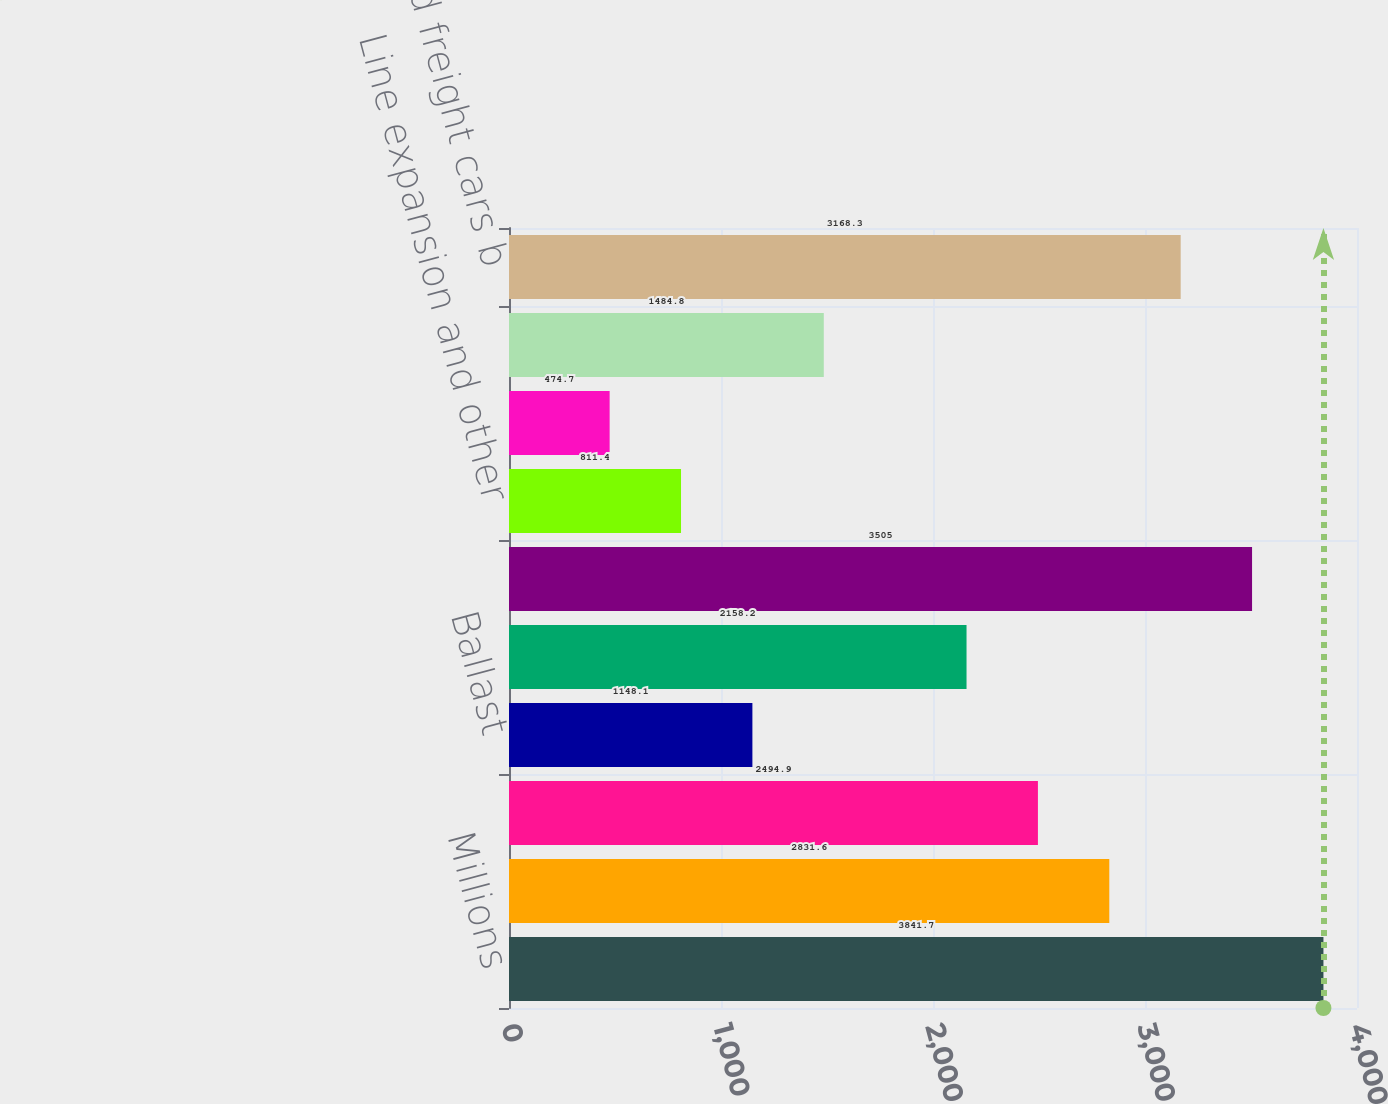Convert chart. <chart><loc_0><loc_0><loc_500><loc_500><bar_chart><fcel>Millions<fcel>Rail and other track material<fcel>Ties<fcel>Ballast<fcel>Other a<fcel>Total road infrastructure<fcel>Line expansion and other<fcel>Commercial facilities<fcel>Total capacity and commercial<fcel>Locomotives and freight cars b<nl><fcel>3841.7<fcel>2831.6<fcel>2494.9<fcel>1148.1<fcel>2158.2<fcel>3505<fcel>811.4<fcel>474.7<fcel>1484.8<fcel>3168.3<nl></chart> 